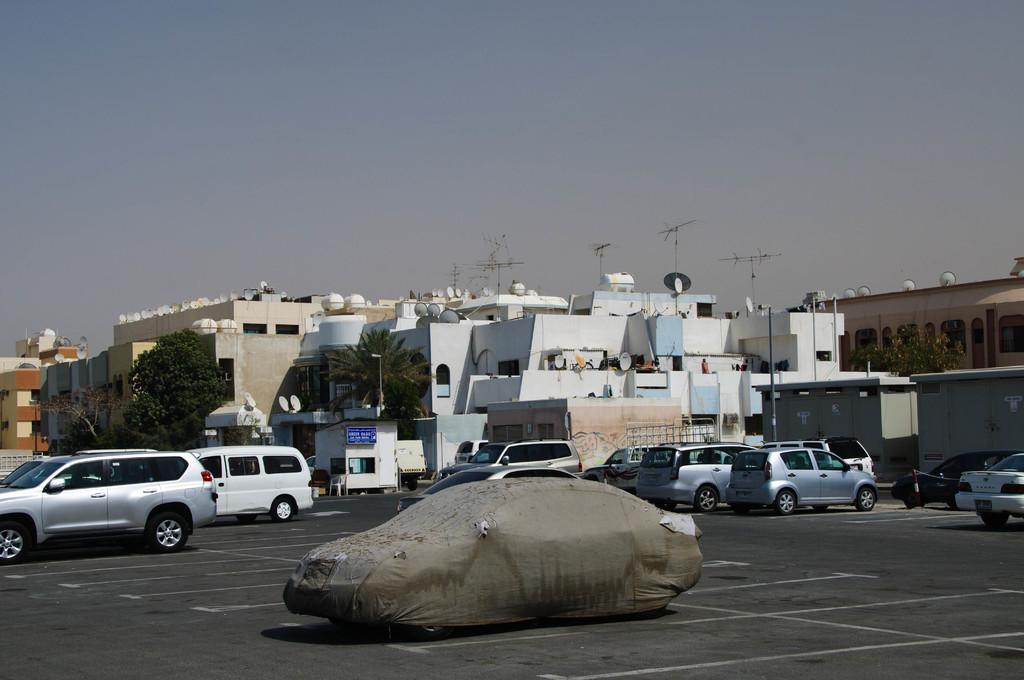What can be seen parked in the image? There are cars parked in the image. What is visible in the background of the image? There are buildings in the background of the image. What type of vegetation is present in the image? There are trees in the image. What structures can be seen on top of the buildings in the image? There are antennas in the image. What is the condition of the sky in the image? The sky is clear in the image. Can you tell me how many prisoners are visible in the image? There are no prisoners present in the image. What type of hobby is being performed by the trees in the image? Trees do not have hobbies; they are inanimate objects. 